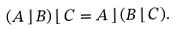<formula> <loc_0><loc_0><loc_500><loc_500>( A \, \rfloor \, B ) \, \lfloor \, C = A \, \rfloor \, ( B \, \lfloor \, C ) .</formula> 